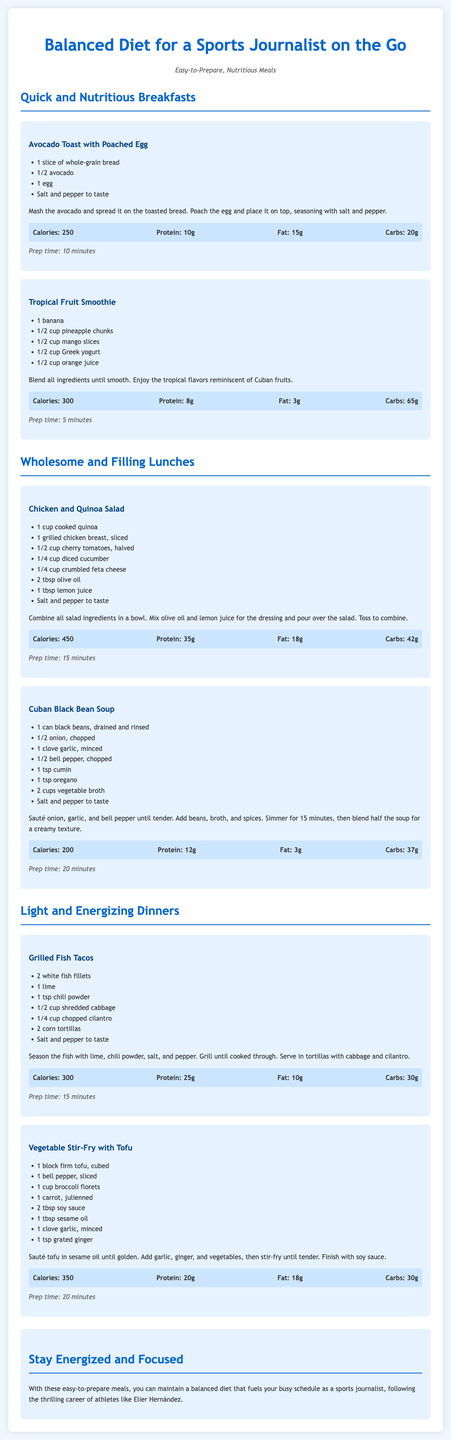What is the title of the document? The title is prominently displayed at the top of the document and summarizes its content.
Answer: Balanced Diet for a Sports Journalist on the Go How many quick breakfast options are there? The document lists two quick breakfast options under the relevant section.
Answer: 2 What is the prep time for the Chicken and Quinoa Salad? The prep time for this meal is stated clearly in its description.
Answer: 15 minutes What is the main protein source in the Grilled Fish Tacos? Protein sources are indicated in the meal descriptions, specifying the main ingredients.
Answer: Fish How many calories does the Tropical Fruit Smoothie contain? The specific calorie content is provided for each meal in the nutrition section.
Answer: 300 What meal contains black beans? This meal title and ingredients highlight the use of black beans clearly.
Answer: Cuban Black Bean Soup What type of cheese is included in the Chicken and Quinoa Salad? The salad ingredients list explicitly mentions this type of cheese.
Answer: Feta cheese What is the main vegetable in the Vegetable Stir-Fry with Tofu? The main vegetable is highlighted within the ingredients list and recipe description.
Answer: Broccoli How does the document suggest maintaining energy as a sports journalist? The conclusion section summarizes the intent of the meal plan for busy professionals.
Answer: Stay energized and focused 